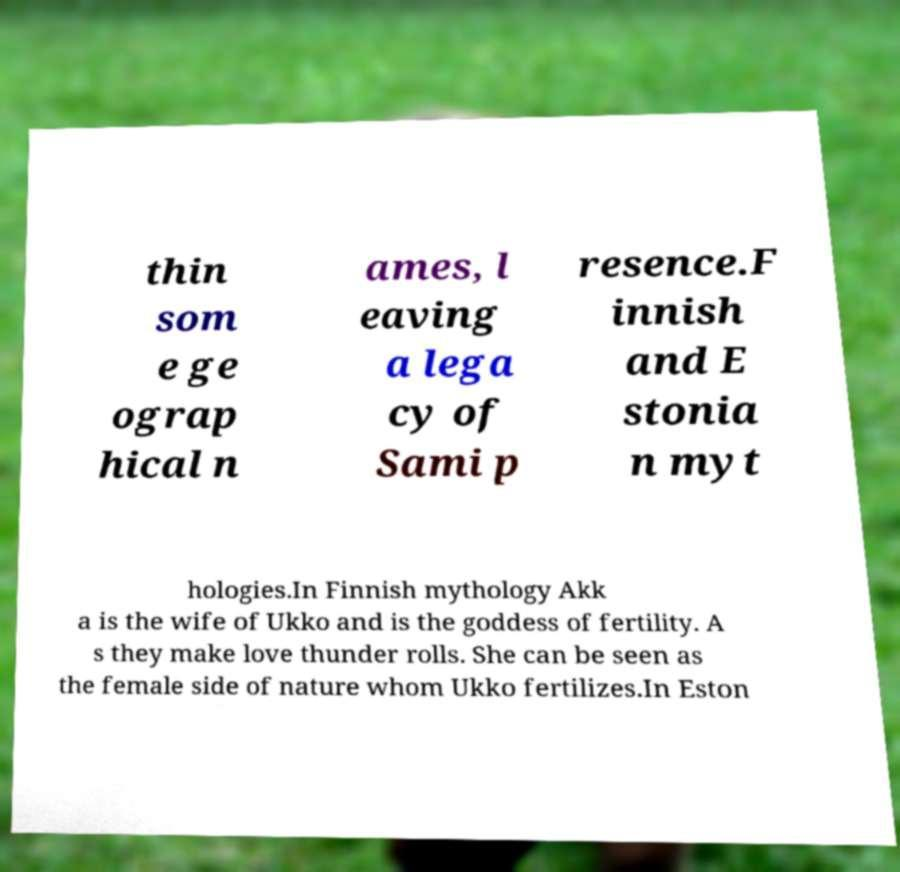Can you read and provide the text displayed in the image?This photo seems to have some interesting text. Can you extract and type it out for me? thin som e ge ograp hical n ames, l eaving a lega cy of Sami p resence.F innish and E stonia n myt hologies.In Finnish mythology Akk a is the wife of Ukko and is the goddess of fertility. A s they make love thunder rolls. She can be seen as the female side of nature whom Ukko fertilizes.In Eston 